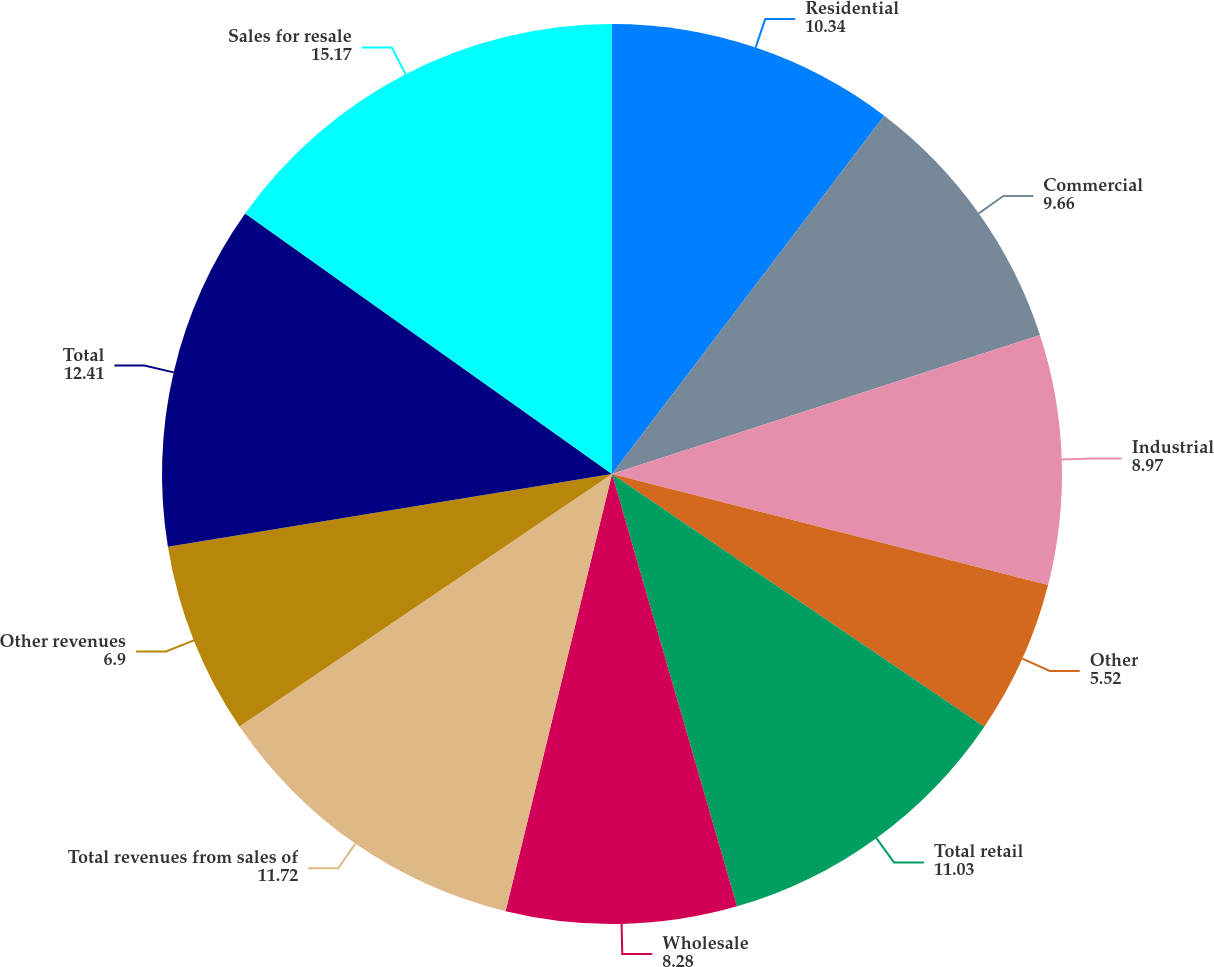Convert chart. <chart><loc_0><loc_0><loc_500><loc_500><pie_chart><fcel>Residential<fcel>Commercial<fcel>Industrial<fcel>Other<fcel>Total retail<fcel>Wholesale<fcel>Total revenues from sales of<fcel>Other revenues<fcel>Total<fcel>Sales for resale<nl><fcel>10.34%<fcel>9.66%<fcel>8.97%<fcel>5.52%<fcel>11.03%<fcel>8.28%<fcel>11.72%<fcel>6.9%<fcel>12.41%<fcel>15.17%<nl></chart> 